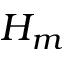Convert formula to latex. <formula><loc_0><loc_0><loc_500><loc_500>H _ { m }</formula> 